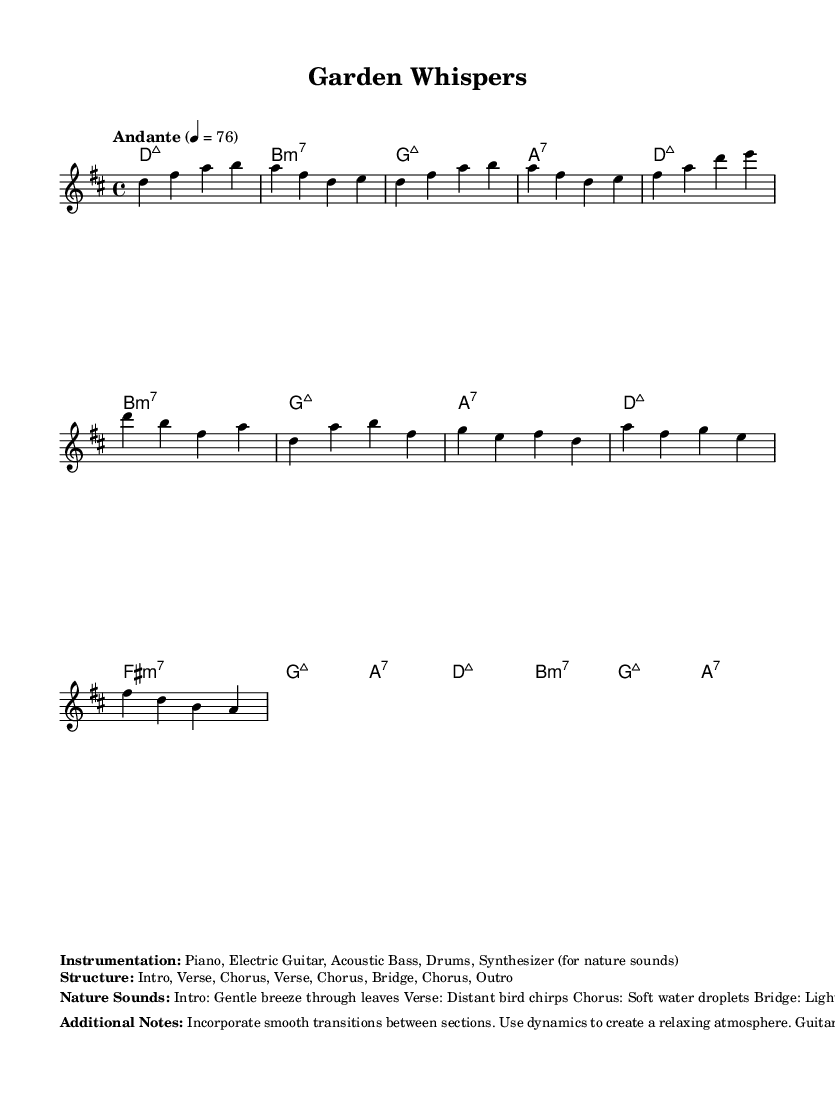What is the key signature of this music? The key signature indicated is D major, which has two sharps (F# and C#). This can be inferred from the global section of the provided code where the key is defined as "d major."
Answer: D major What is the time signature of this music? The time signature shown in the global section is 4/4, which means there are four beats in each measure. This is indicated directly as "\time 4/4" in the global settings.
Answer: 4/4 What is the tempo marking for this piece? The tempo marking is given as "Andante" with a metronome marking of 76, which indicates a moderate pace. This information is stated within the global section of the code.
Answer: Andante, 76 How many sections are there in the structure of the music? The structure is outlined explicitly in the markup section, listing the sections as Intro, Verse, Chorus, Verse, Chorus, Bridge, Chorus, and Outro, which totals to 8 sections.
Answer: 8 What instruments are used in this composition? The instruments are specified in the markup section as Piano, Electric Guitar, Acoustic Bass, Drums, and Synthesizer (for nature sounds). This provides a clear list of the instrumentation for the piece.
Answer: Piano, Electric Guitar, Acoustic Bass, Drums, Synthesizer What nature sounds are associated with the Chorus? The nature sounds indicated for the Chorus section are "Soft water droplets." This is listed in the markup section that describes nature sounds for different parts of the composition.
Answer: Soft water droplets Which section has distant bird chirps? The distant bird chirps are associated with the Verse section as mentioned in the nature sounds markup. This indicates the specific sounds that should be integrated into that part of the music.
Answer: Verse 